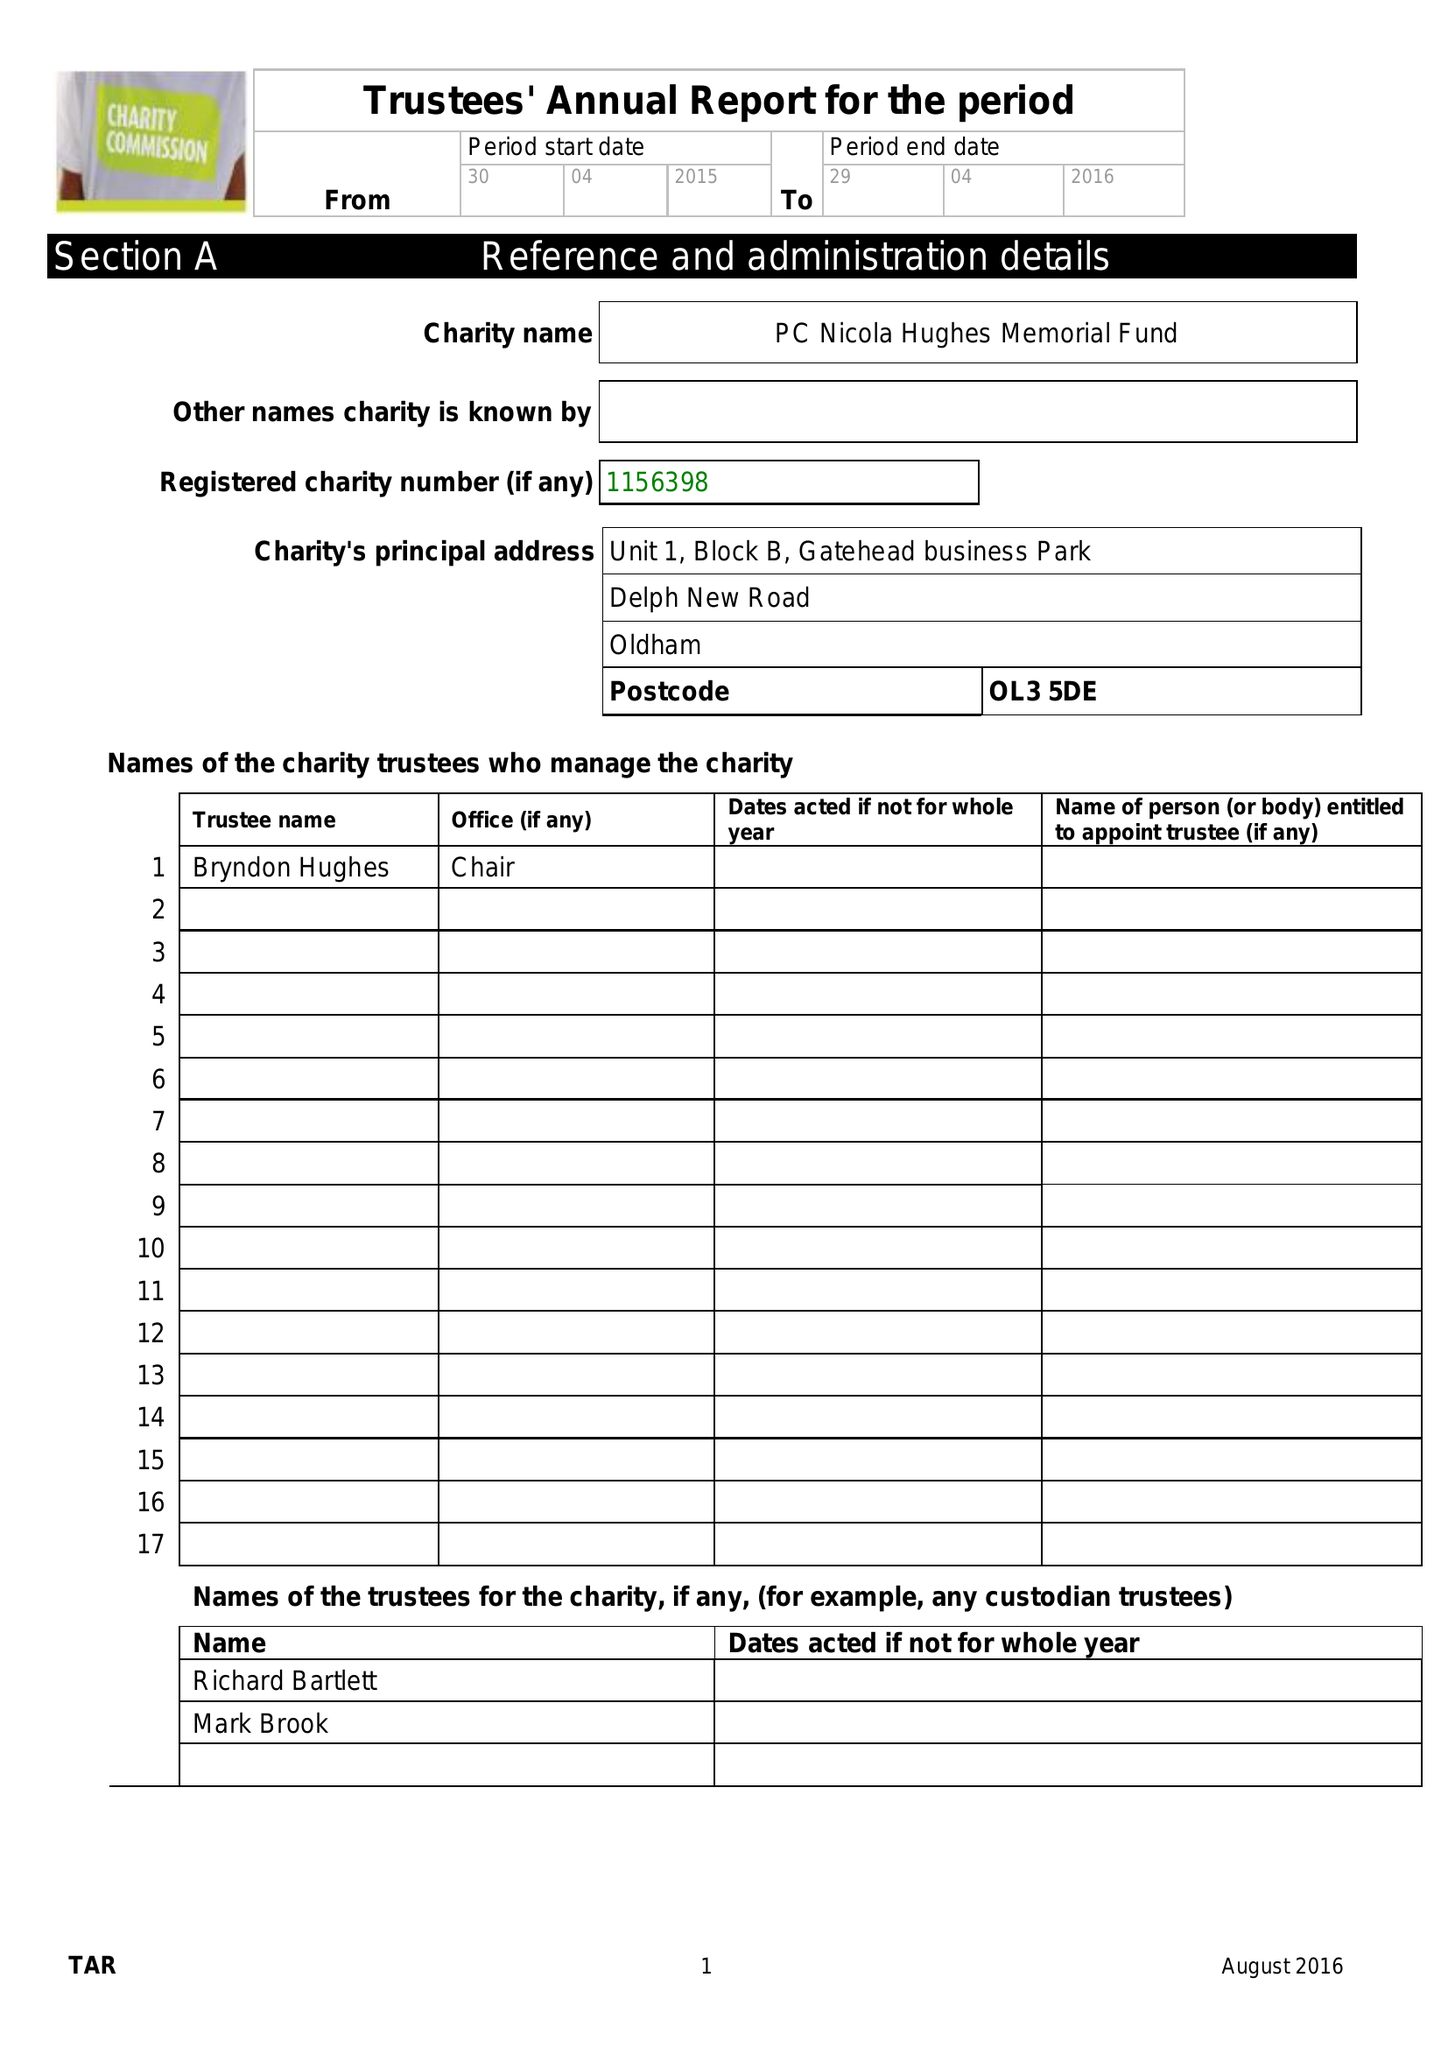What is the value for the address__street_line?
Answer the question using a single word or phrase. DELPH NEW ROAD 